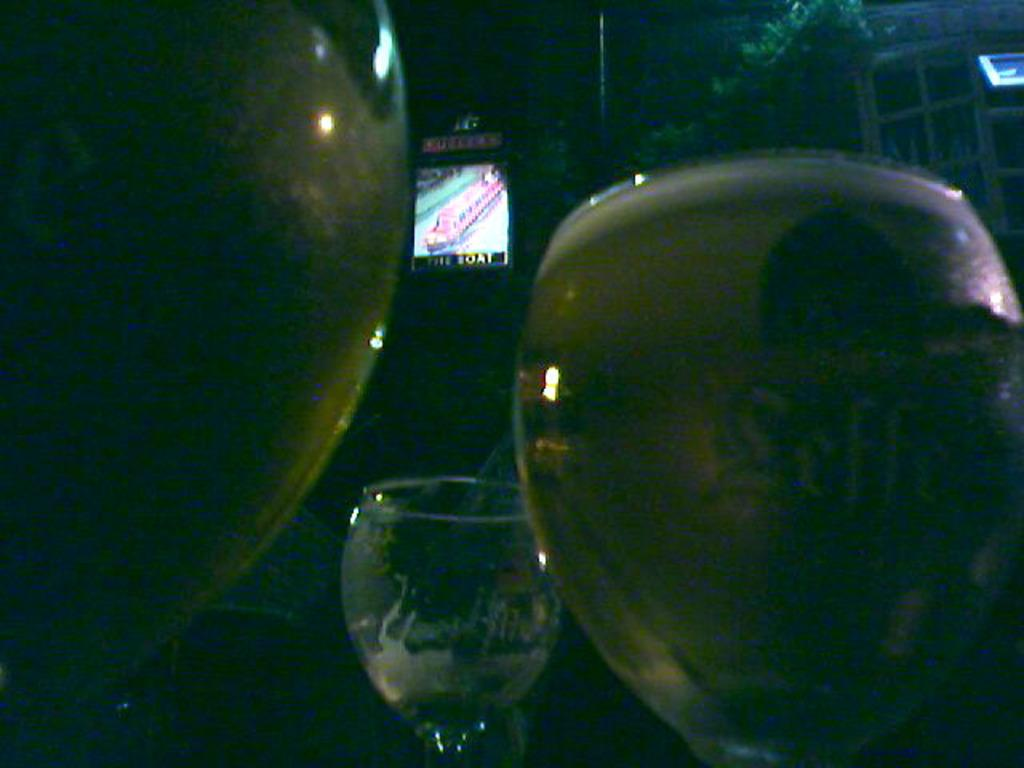What time of day is depicted in the image? The image was taken during night time. What objects can be seen in the image? There are glasses and a television screen in the image. Where is the window located in the image? The window is on the right side of the image. What type of beast is lurking outside the window in the image? There is no beast visible outside the window in the image. What type of poison is being used in the battle depicted in the image? There is no battle depicted in the image, so it is not possible to determine if any poison is being used. 